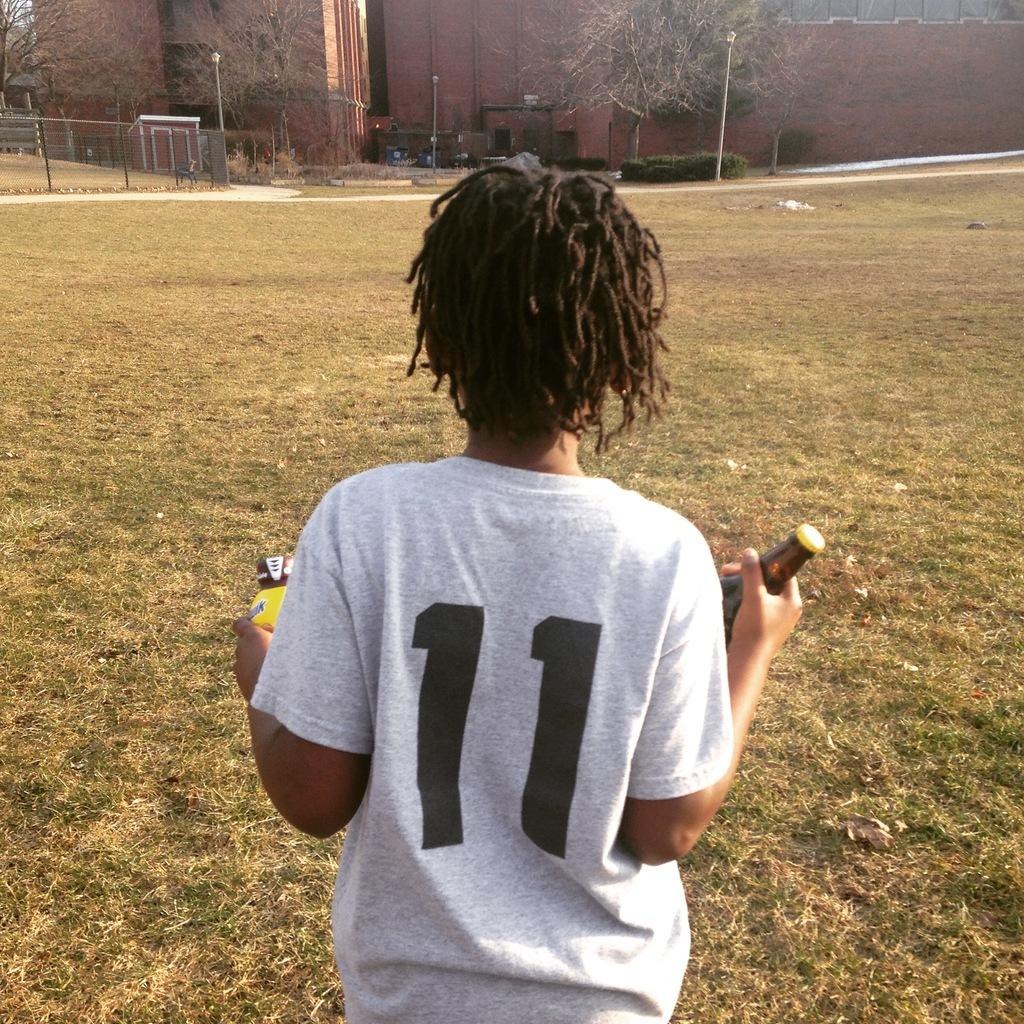<image>
Summarize the visual content of the image. Boy wearing a white shirt with a number 11 on it. 